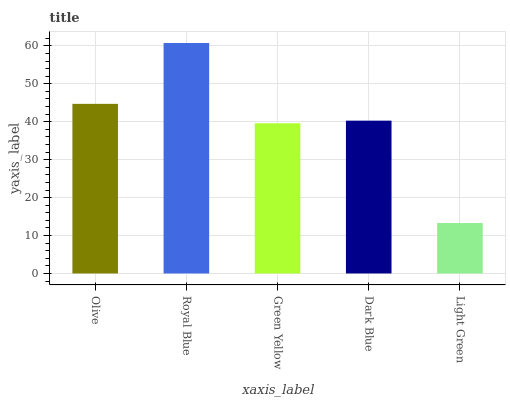Is Green Yellow the minimum?
Answer yes or no. No. Is Green Yellow the maximum?
Answer yes or no. No. Is Royal Blue greater than Green Yellow?
Answer yes or no. Yes. Is Green Yellow less than Royal Blue?
Answer yes or no. Yes. Is Green Yellow greater than Royal Blue?
Answer yes or no. No. Is Royal Blue less than Green Yellow?
Answer yes or no. No. Is Dark Blue the high median?
Answer yes or no. Yes. Is Dark Blue the low median?
Answer yes or no. Yes. Is Royal Blue the high median?
Answer yes or no. No. Is Royal Blue the low median?
Answer yes or no. No. 